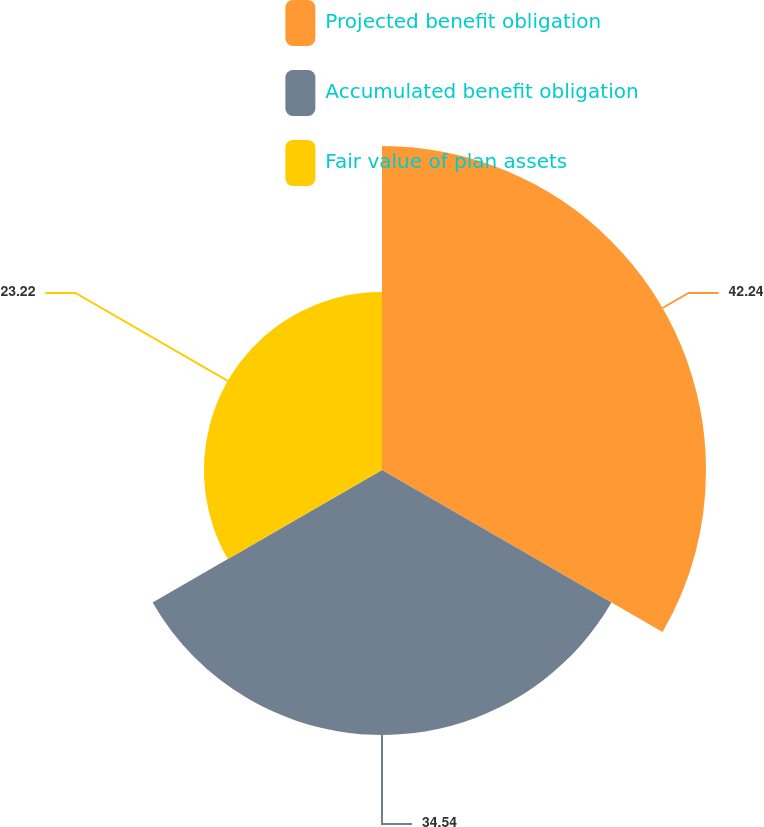<chart> <loc_0><loc_0><loc_500><loc_500><pie_chart><fcel>Projected benefit obligation<fcel>Accumulated benefit obligation<fcel>Fair value of plan assets<nl><fcel>42.24%<fcel>34.54%<fcel>23.22%<nl></chart> 